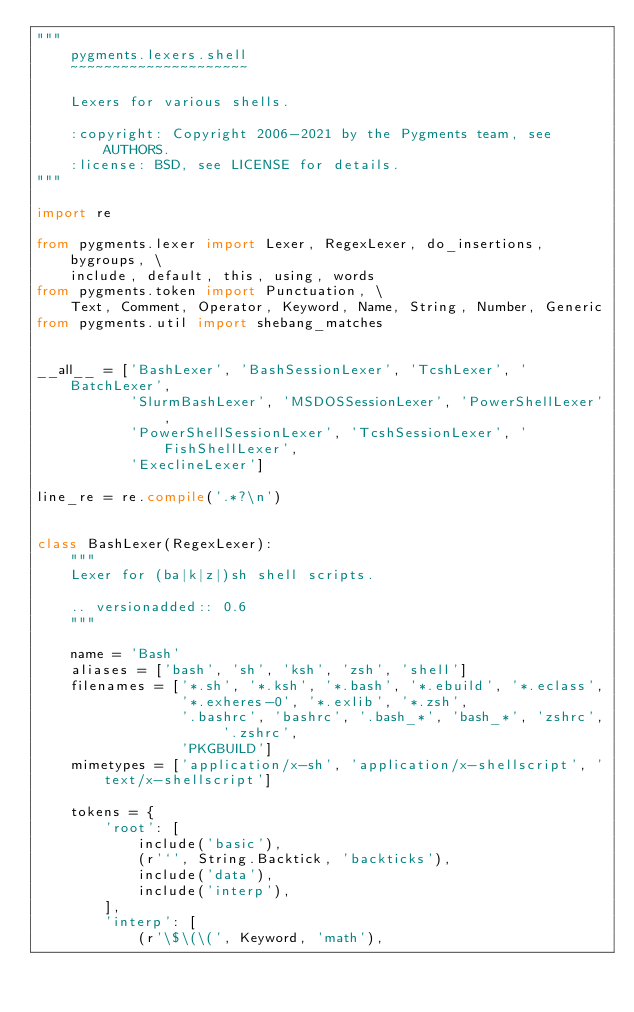<code> <loc_0><loc_0><loc_500><loc_500><_Python_>"""
    pygments.lexers.shell
    ~~~~~~~~~~~~~~~~~~~~~

    Lexers for various shells.

    :copyright: Copyright 2006-2021 by the Pygments team, see AUTHORS.
    :license: BSD, see LICENSE for details.
"""

import re

from pygments.lexer import Lexer, RegexLexer, do_insertions, bygroups, \
    include, default, this, using, words
from pygments.token import Punctuation, \
    Text, Comment, Operator, Keyword, Name, String, Number, Generic
from pygments.util import shebang_matches


__all__ = ['BashLexer', 'BashSessionLexer', 'TcshLexer', 'BatchLexer',
           'SlurmBashLexer', 'MSDOSSessionLexer', 'PowerShellLexer',
           'PowerShellSessionLexer', 'TcshSessionLexer', 'FishShellLexer',
           'ExeclineLexer']

line_re = re.compile('.*?\n')


class BashLexer(RegexLexer):
    """
    Lexer for (ba|k|z|)sh shell scripts.

    .. versionadded:: 0.6
    """

    name = 'Bash'
    aliases = ['bash', 'sh', 'ksh', 'zsh', 'shell']
    filenames = ['*.sh', '*.ksh', '*.bash', '*.ebuild', '*.eclass',
                 '*.exheres-0', '*.exlib', '*.zsh',
                 '.bashrc', 'bashrc', '.bash_*', 'bash_*', 'zshrc', '.zshrc',
                 'PKGBUILD']
    mimetypes = ['application/x-sh', 'application/x-shellscript', 'text/x-shellscript']

    tokens = {
        'root': [
            include('basic'),
            (r'`', String.Backtick, 'backticks'),
            include('data'),
            include('interp'),
        ],
        'interp': [
            (r'\$\(\(', Keyword, 'math'),</code> 